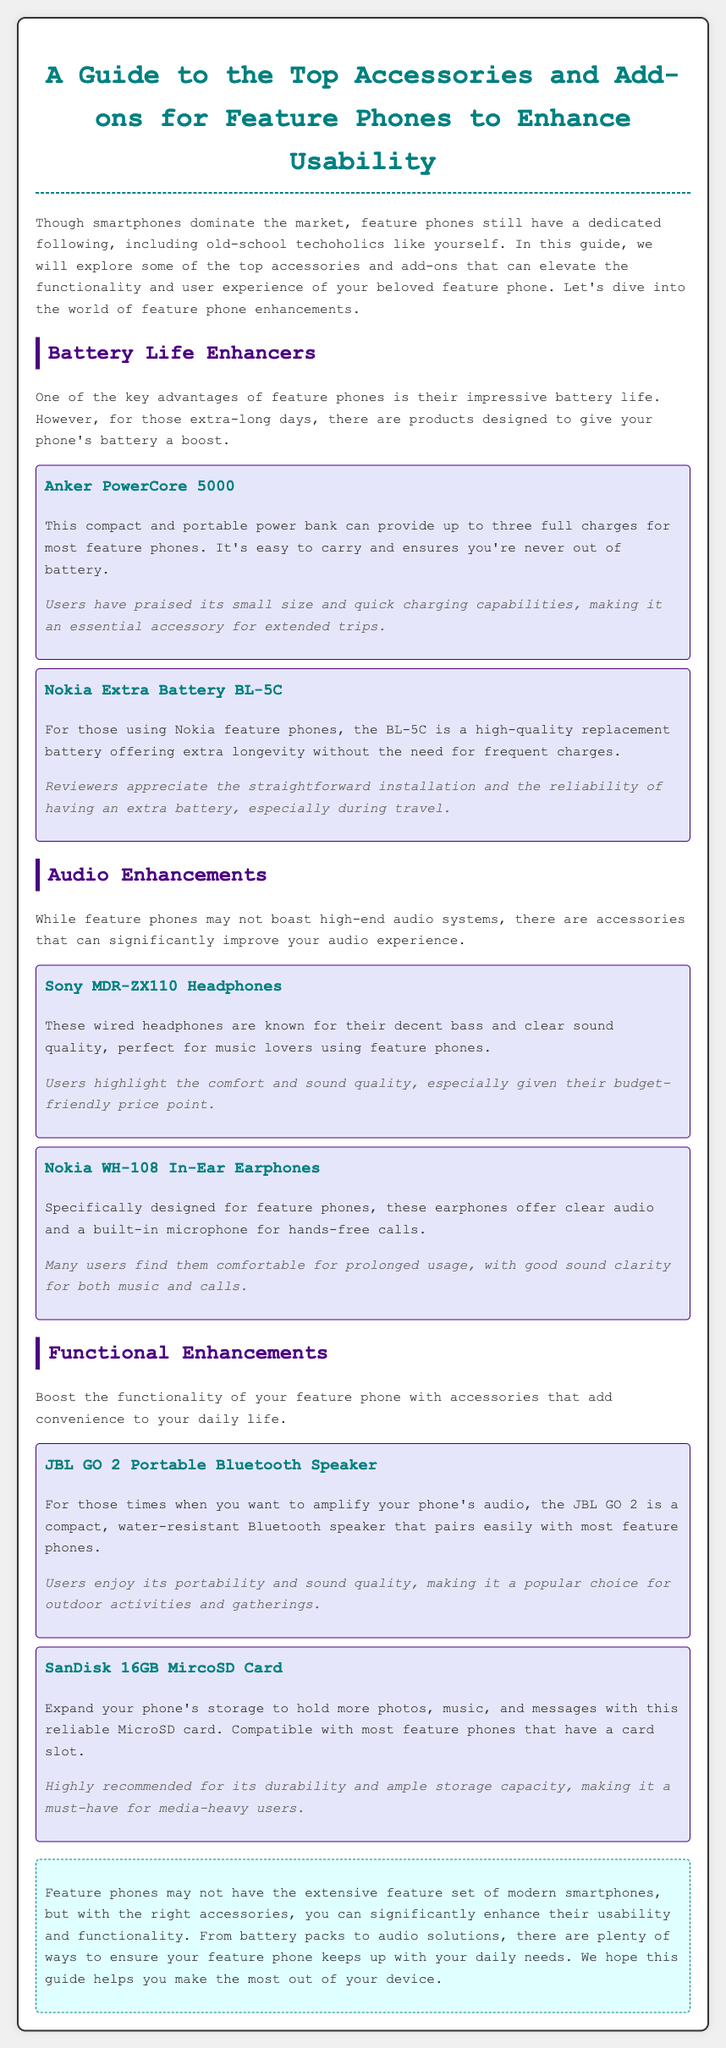what is the title of the document? The title of the document is stated in the header of the HTML file.
Answer: A Guide to the Top Accessories and Add-ons for Feature Phones to Enhance Usability how many charges can the Anker PowerCore 5000 provide? The document specifies the charging capability of the Anker PowerCore 5000 in the description.
Answer: three full charges what is the model number of the Nokia Extra Battery mentioned? The model number of the Nokia battery is mentioned in the accessory description section.
Answer: BL-5C which headphones are known for decent bass and clear sound quality? The document identifies a specific accessory related to audio enhancements.
Answer: Sony MDR-ZX110 Headphones what accessory is recommended for expanding storage? The document lists an accessory specifically for storage enhancement.
Answer: SanDisk 16GB MircoSD Card which accessory is noted for its portability and sound quality? The JBL GO 2 Portable Bluetooth Speaker is highlighted in the user experience section for its features.
Answer: JBL GO 2 what are the primary enhancements discussed in the document? The document is organized into sections, and this question pertains to the main topics covered.
Answer: Battery Life Enhancers, Audio Enhancements, Functional Enhancements why do users appreciate the Nokia WH-108 In-Ear Earphones? The document provides user feedback regarding comfort and sound clarity of the earphones.
Answer: comfortable for prolonged usage what color scheme is used for the headings in the document? The document indicates the color used for titles, providing insight into its design.
Answer: teal and purple 